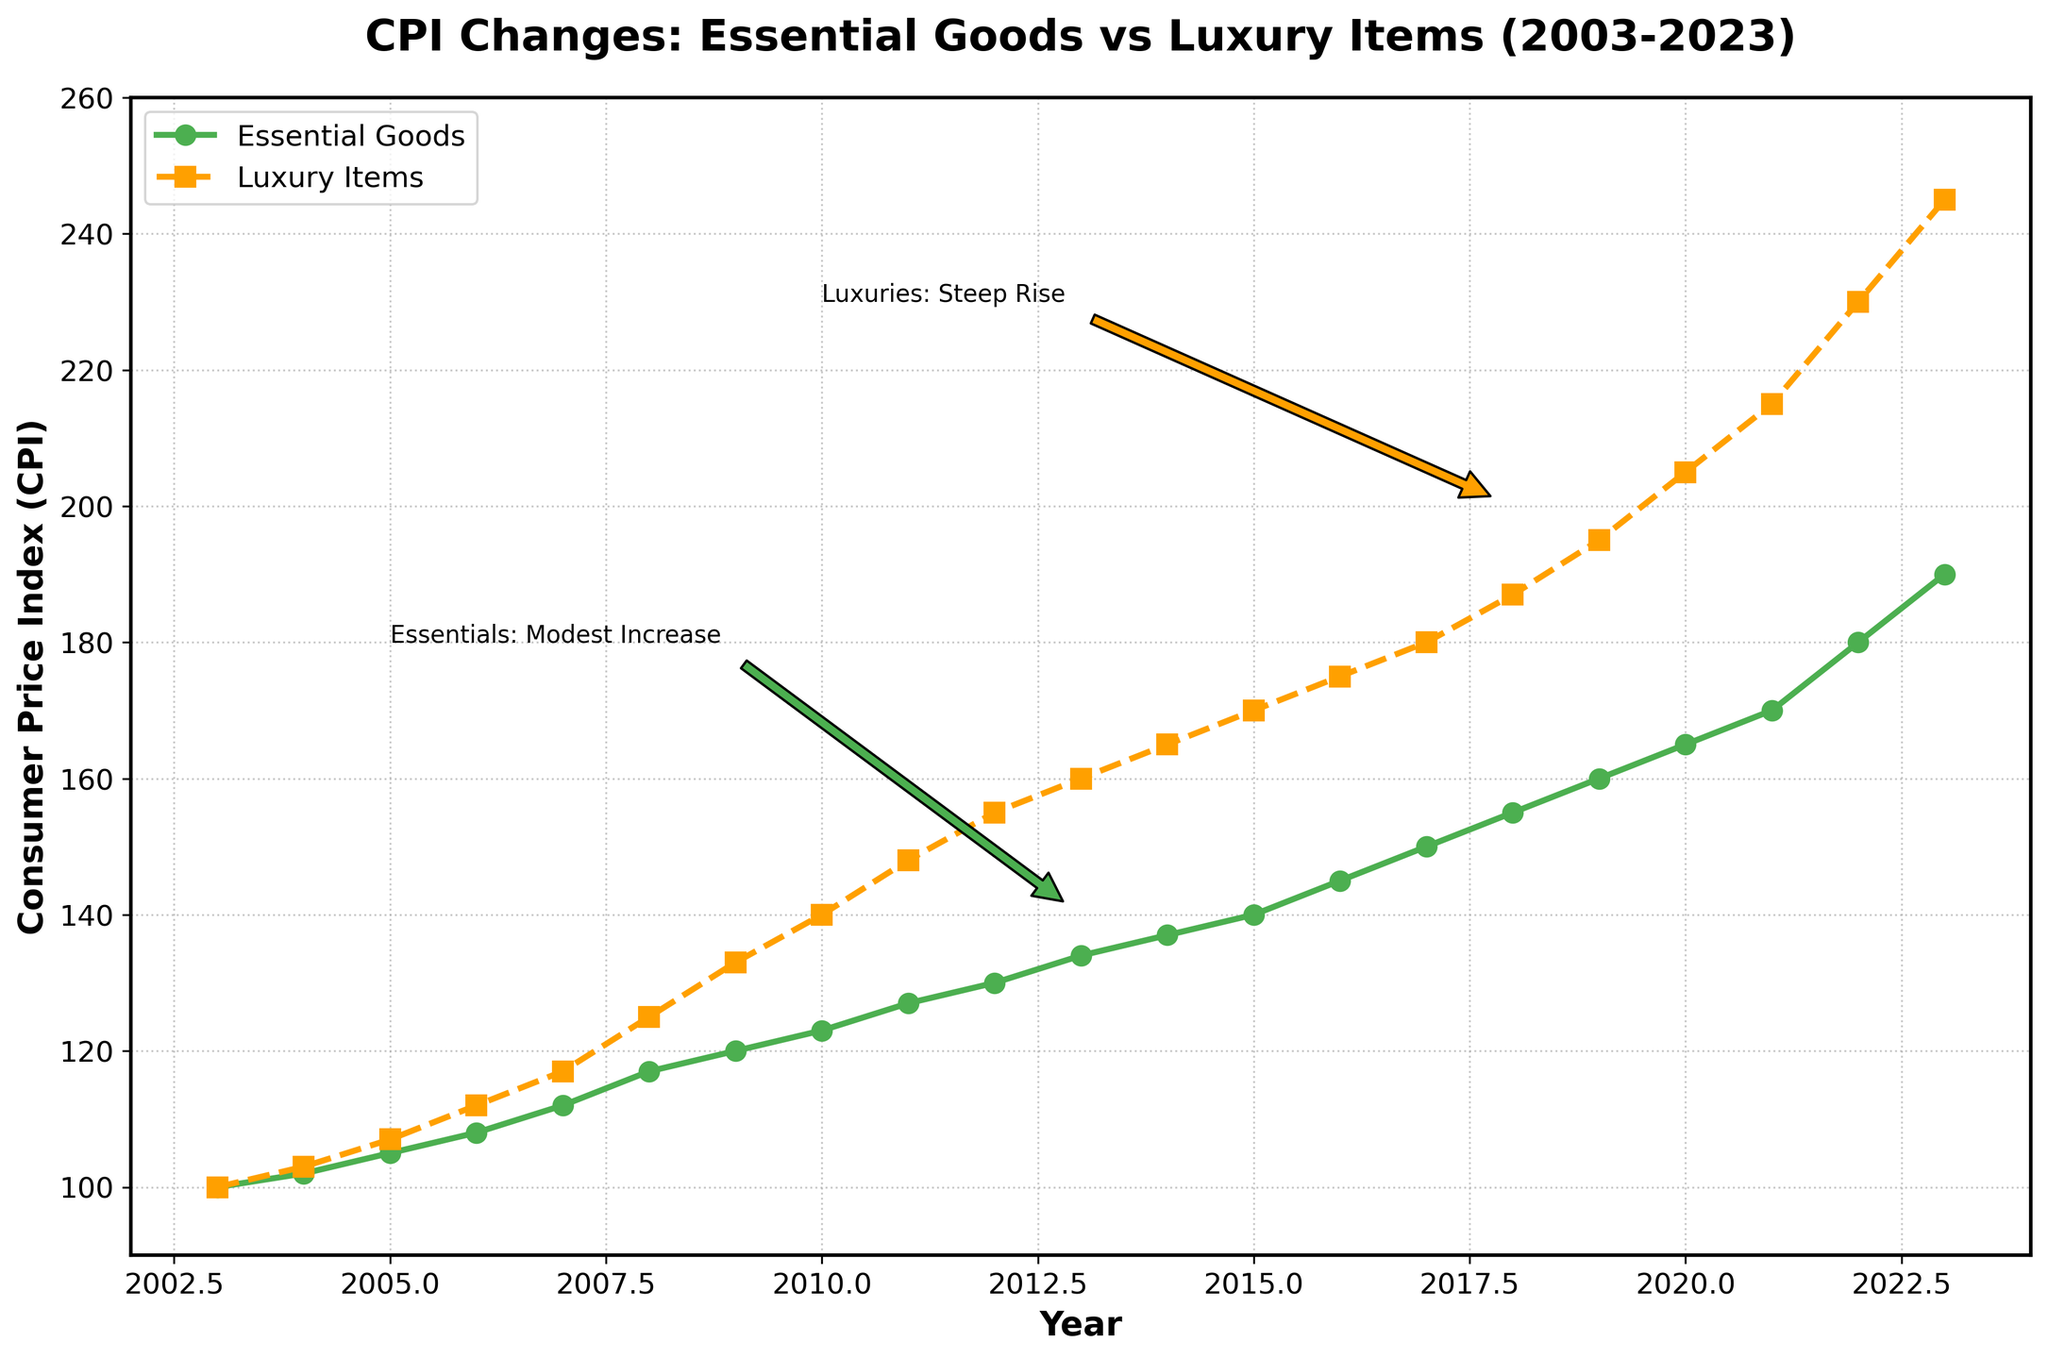What is the title of the plot? You can find the title at the top of the plot, which reads "CPI Changes: Essential Goods vs Luxury Items (2003-2023)."
Answer: CPI Changes: Essential Goods vs Luxury Items (2003-2023) What are the x and y-axis labels? The x-axis label is "Year" and the y-axis label is "Consumer Price Index (CPI)."
Answer: Year; Consumer Price Index (CPI) What colors represent essential goods and luxury items in the plot? In the plot, essential goods are represented by green lines, and luxury items are represented by amber/orange lines.
Answer: Green and Amber/Orange How many data points are there for essential goods from 2003 to 2023? Each year from 2003 to 2023 corresponds to one data point. Count the number of years from 2003 to 2023, inclusive. There are 21 data points.
Answer: 21 By how much did the CPI for essential goods increase from 2003 to 2023? The CPI for essential goods in 2003 is 100, and in 2023 it is 190. Calculate the increase by subtracting the 2003 value from the 2023 value: 190 - 100 = 90.
Answer: 90 During which year did the CPI for luxury items reach 200? Find the point where the CPI for luxury items first meets or exceeds 200. Based on the plot, this occurs around 2019.
Answer: 2019 What is the difference in CPI between essential goods and luxury items in 2023? In 2023, the CPI for essential goods is 190 and for luxury items is 245. The difference is 245 - 190 = 55.
Answer: 55 What does the annotation "Essentials: Modest Increase" refer to? The annotation points to the general trend of essential goods, indicating a steady and modest rise in CPI over the years.
Answer: The steady rise of essential goods' CPI How does the CPI trend for essential goods compare to luxury items over the two decades? Both CPIs trend upwards, but the luxury items' CPI increases faster and more steeply than the essential goods' CPI, as indicated by the annotations and the steeper slope of the orange line.
Answer: Luxury items increase more steeply than essential goods Which category saw a more significant percentage increase in CPI from 2003 to 2023? Calculate the percentage increase for each category. For essential goods: (190 - 100) / 100 * 100% = 90%. For luxury items: (245 - 100) / 100 * 100% = 145%. Luxury items saw a more significant percentage increase.
Answer: Luxury items saw a larger percentage increase 